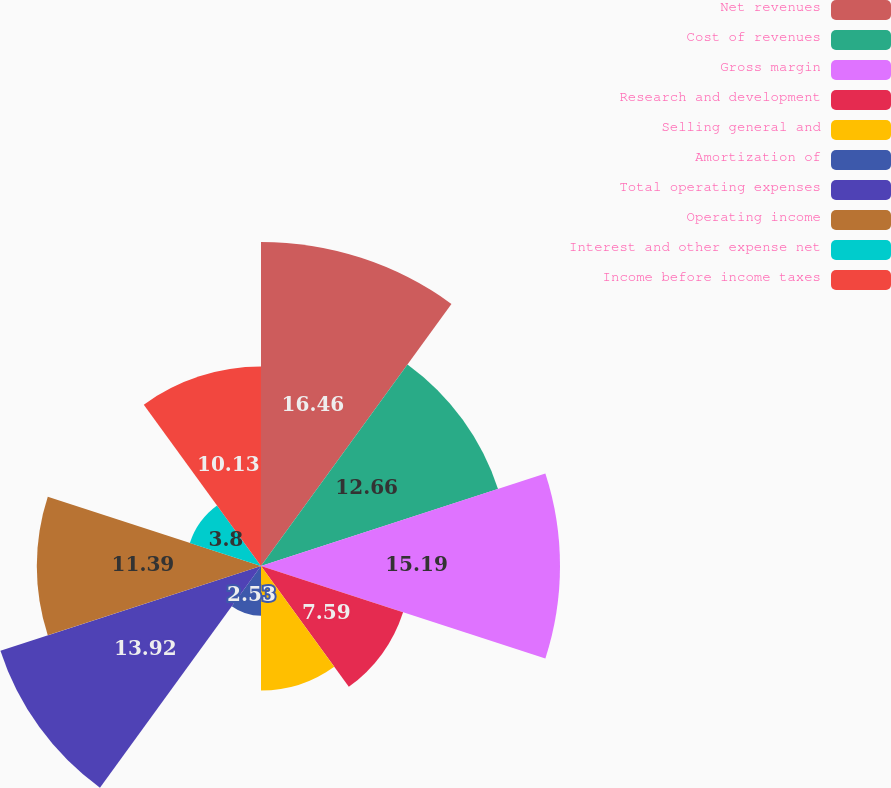<chart> <loc_0><loc_0><loc_500><loc_500><pie_chart><fcel>Net revenues<fcel>Cost of revenues<fcel>Gross margin<fcel>Research and development<fcel>Selling general and<fcel>Amortization of<fcel>Total operating expenses<fcel>Operating income<fcel>Interest and other expense net<fcel>Income before income taxes<nl><fcel>16.46%<fcel>12.66%<fcel>15.19%<fcel>7.59%<fcel>6.33%<fcel>2.53%<fcel>13.92%<fcel>11.39%<fcel>3.8%<fcel>10.13%<nl></chart> 